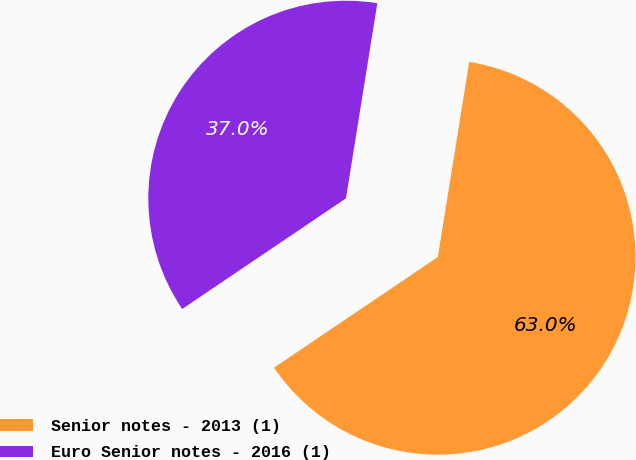<chart> <loc_0><loc_0><loc_500><loc_500><pie_chart><fcel>Senior notes - 2013 (1)<fcel>Euro Senior notes - 2016 (1)<nl><fcel>63.01%<fcel>36.99%<nl></chart> 